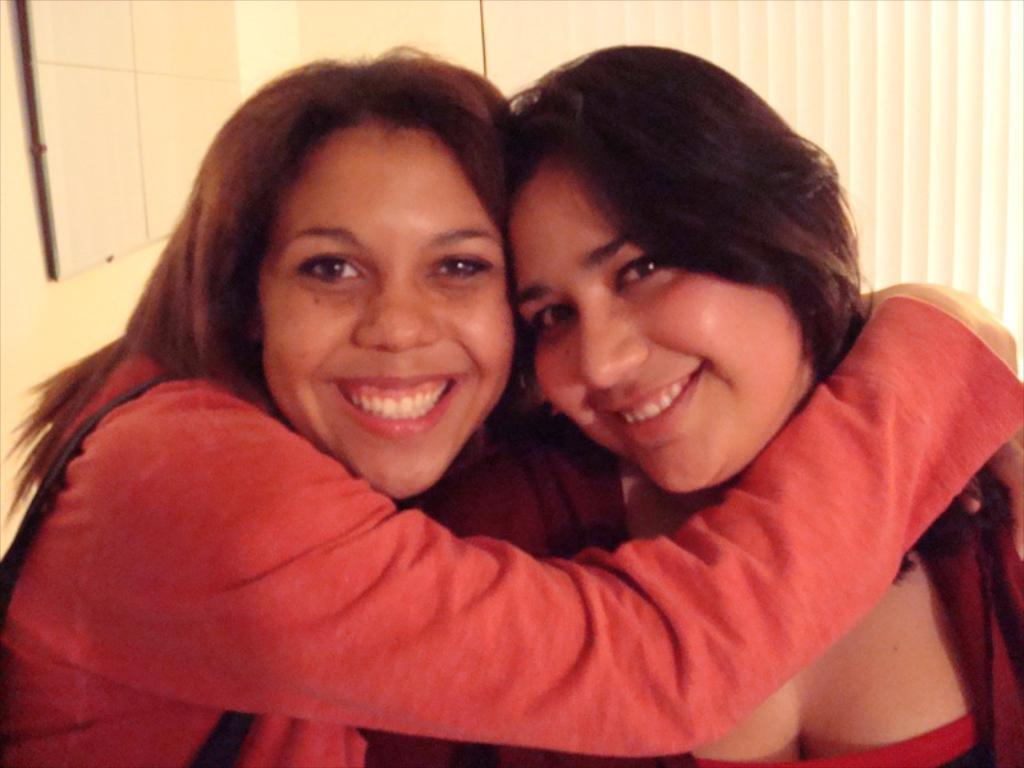How many people are in the image? There are two women in the image. What are the women doing in the image? The women are holding each other. What can be seen in the background of the image? There is a board on a wall in the background of the image. What type of button is the man wearing in the image? There is no man present in the image, so there is no button to describe. 